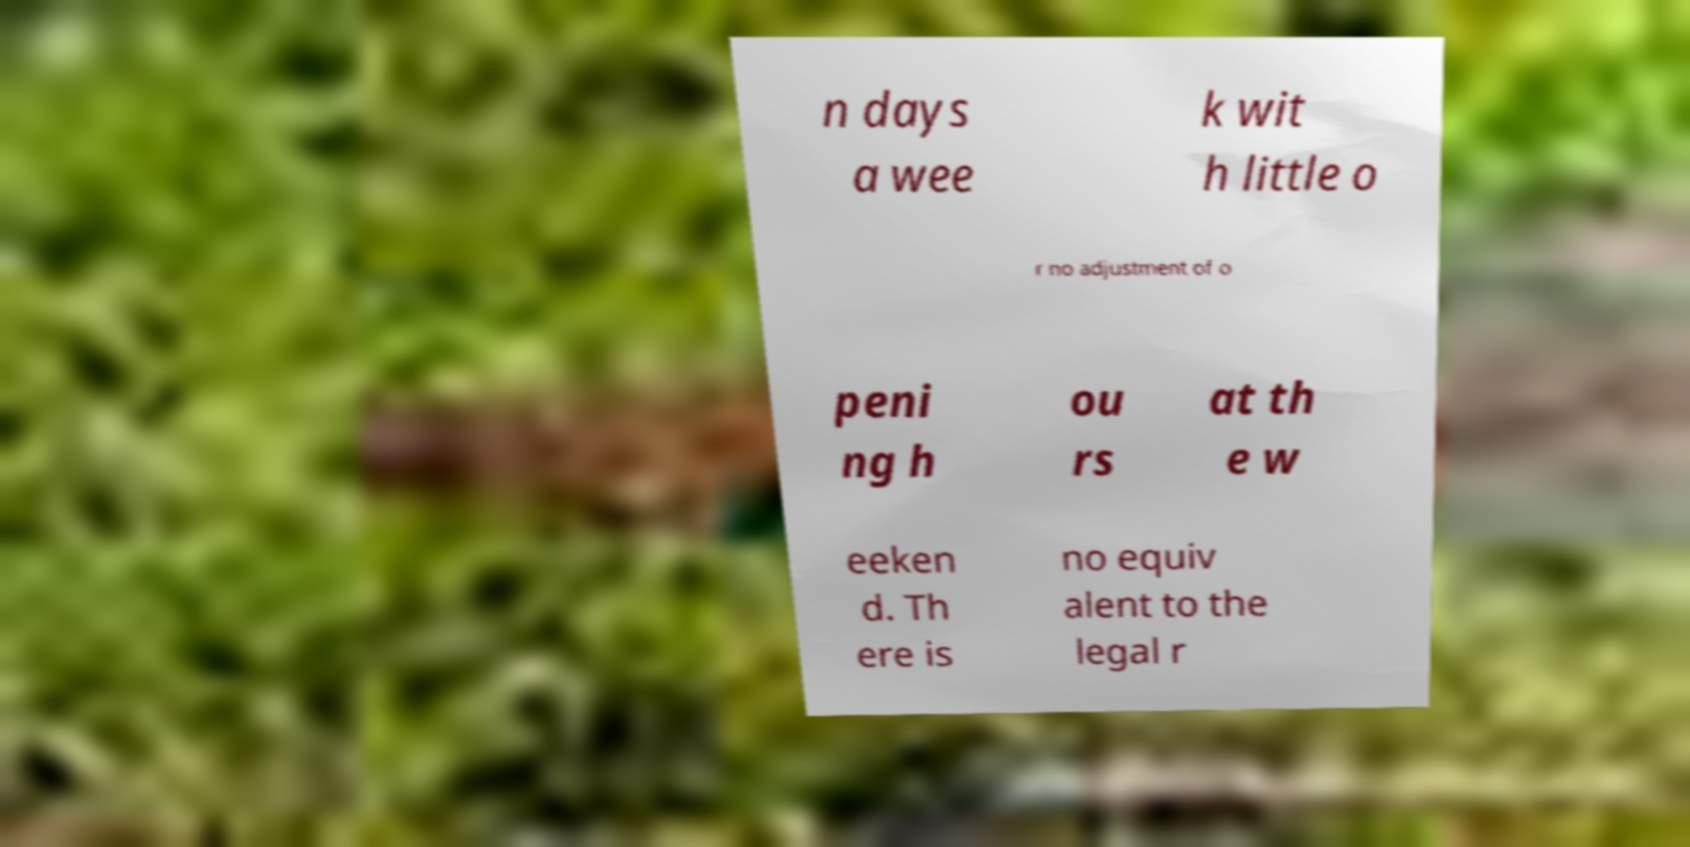Can you accurately transcribe the text from the provided image for me? n days a wee k wit h little o r no adjustment of o peni ng h ou rs at th e w eeken d. Th ere is no equiv alent to the legal r 